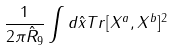<formula> <loc_0><loc_0><loc_500><loc_500>\frac { 1 } { 2 \pi \hat { R } _ { 9 } } \int d \hat { x } T r [ X ^ { a } , X ^ { b } ] ^ { 2 }</formula> 